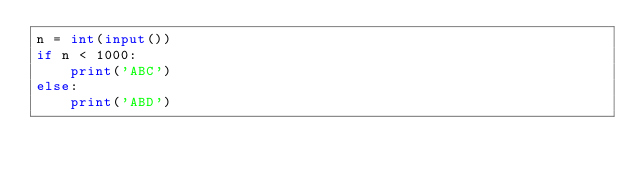Convert code to text. <code><loc_0><loc_0><loc_500><loc_500><_Python_>n = int(input())
if n < 1000:
    print('ABC')
else:
    print('ABD')
</code> 